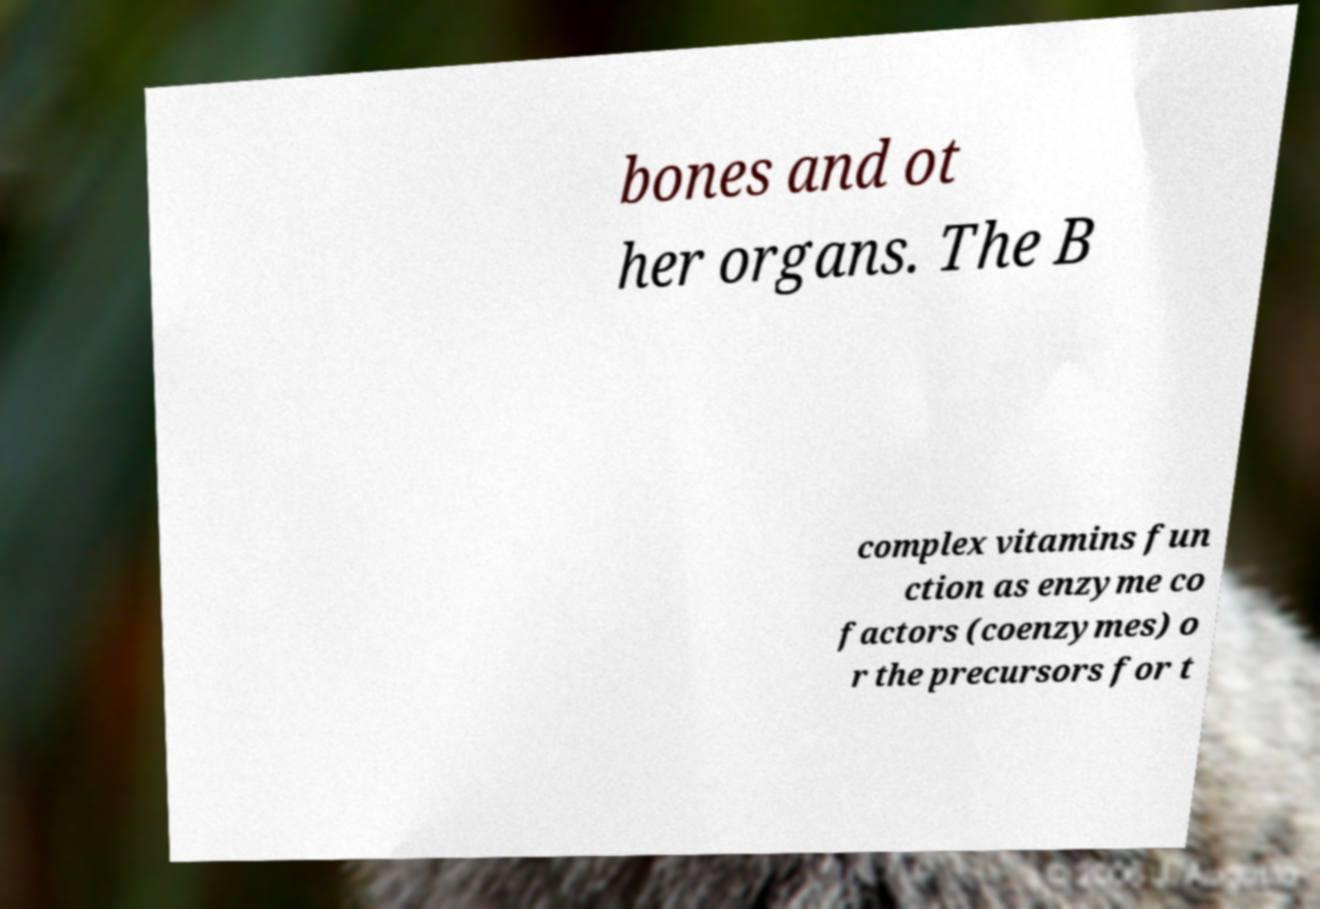There's text embedded in this image that I need extracted. Can you transcribe it verbatim? bones and ot her organs. The B complex vitamins fun ction as enzyme co factors (coenzymes) o r the precursors for t 